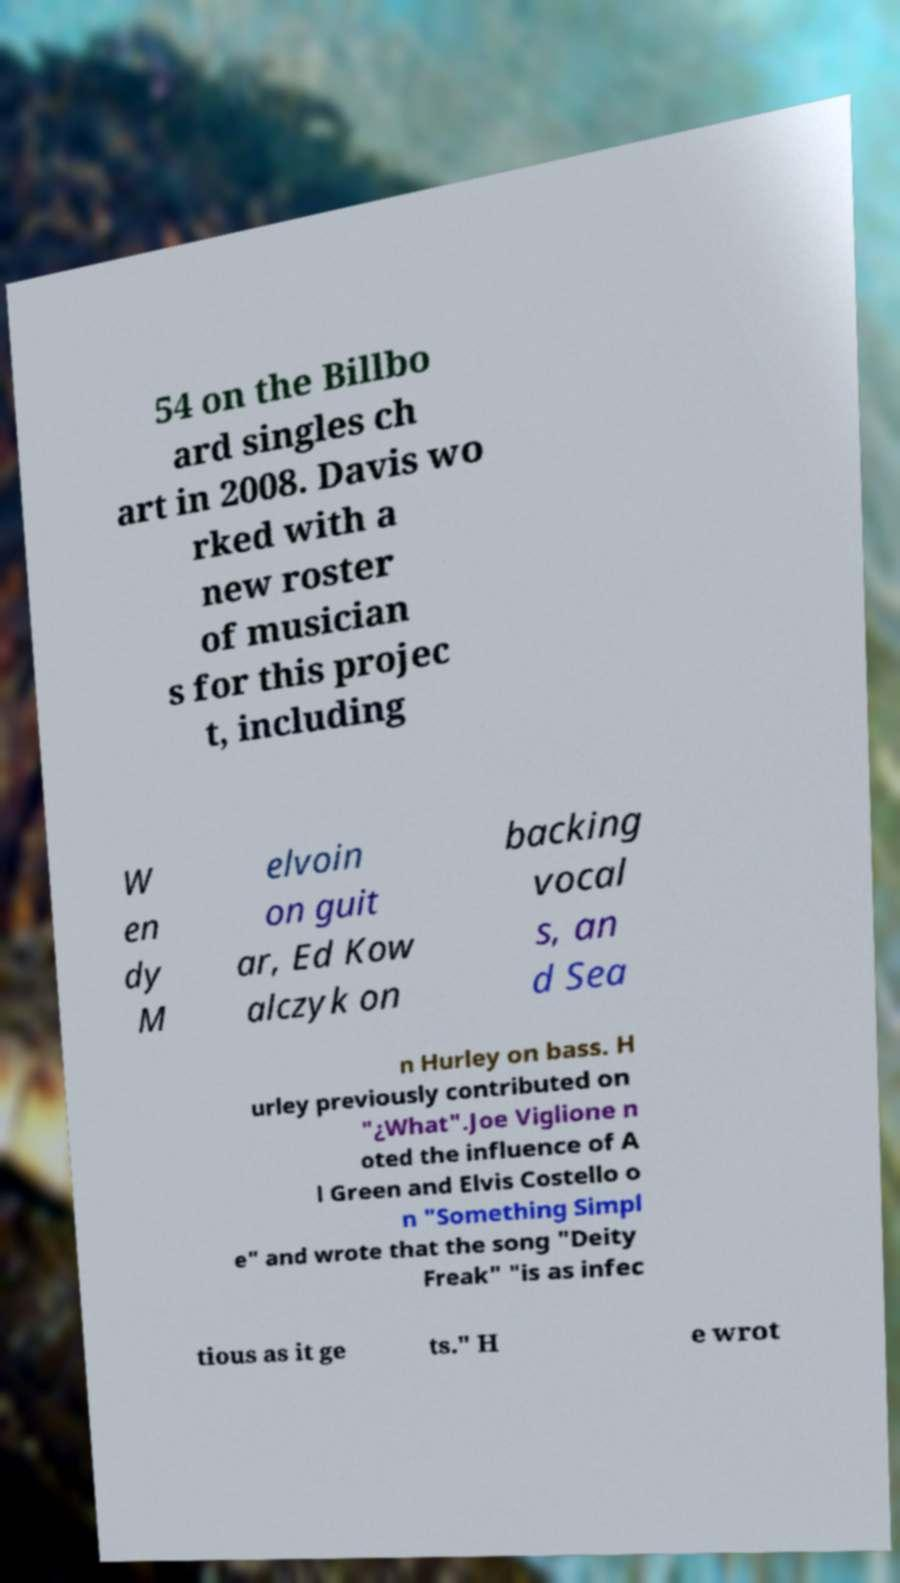Can you accurately transcribe the text from the provided image for me? 54 on the Billbo ard singles ch art in 2008. Davis wo rked with a new roster of musician s for this projec t, including W en dy M elvoin on guit ar, Ed Kow alczyk on backing vocal s, an d Sea n Hurley on bass. H urley previously contributed on "¿What".Joe Viglione n oted the influence of A l Green and Elvis Costello o n "Something Simpl e" and wrote that the song "Deity Freak" "is as infec tious as it ge ts." H e wrot 